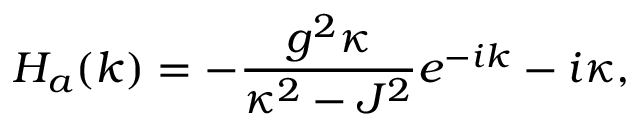Convert formula to latex. <formula><loc_0><loc_0><loc_500><loc_500>H _ { a } ( k ) = - \frac { g ^ { 2 } \kappa } { \kappa ^ { 2 } - J ^ { 2 } } e ^ { - i k } - i \kappa ,</formula> 